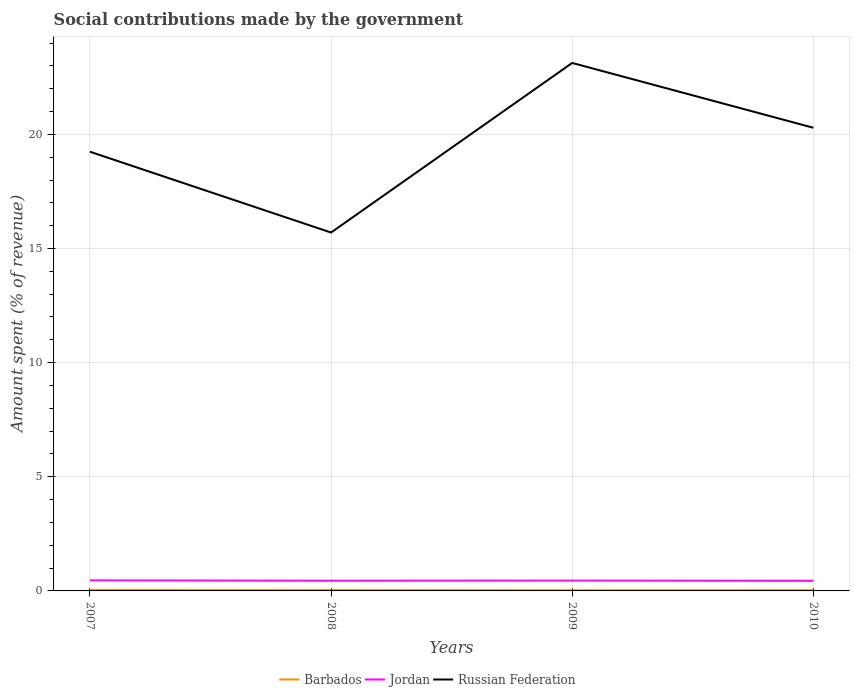Does the line corresponding to Russian Federation intersect with the line corresponding to Jordan?
Give a very brief answer. No. Is the number of lines equal to the number of legend labels?
Your answer should be compact. Yes. Across all years, what is the maximum amount spent (in %) on social contributions in Barbados?
Your response must be concise. 0.03. What is the total amount spent (in %) on social contributions in Jordan in the graph?
Offer a terse response. 0.01. What is the difference between the highest and the second highest amount spent (in %) on social contributions in Jordan?
Your response must be concise. 0.02. Is the amount spent (in %) on social contributions in Barbados strictly greater than the amount spent (in %) on social contributions in Jordan over the years?
Make the answer very short. Yes. How many lines are there?
Provide a succinct answer. 3. What is the difference between two consecutive major ticks on the Y-axis?
Keep it short and to the point. 5. Does the graph contain any zero values?
Your answer should be very brief. No. Where does the legend appear in the graph?
Provide a short and direct response. Bottom center. What is the title of the graph?
Offer a terse response. Social contributions made by the government. What is the label or title of the Y-axis?
Your answer should be compact. Amount spent (% of revenue). What is the Amount spent (% of revenue) in Barbados in 2007?
Offer a very short reply. 0.04. What is the Amount spent (% of revenue) of Jordan in 2007?
Provide a succinct answer. 0.46. What is the Amount spent (% of revenue) in Russian Federation in 2007?
Make the answer very short. 19.24. What is the Amount spent (% of revenue) of Barbados in 2008?
Provide a short and direct response. 0.04. What is the Amount spent (% of revenue) in Jordan in 2008?
Your response must be concise. 0.45. What is the Amount spent (% of revenue) in Russian Federation in 2008?
Make the answer very short. 15.7. What is the Amount spent (% of revenue) of Barbados in 2009?
Your answer should be very brief. 0.03. What is the Amount spent (% of revenue) in Jordan in 2009?
Your answer should be very brief. 0.45. What is the Amount spent (% of revenue) of Russian Federation in 2009?
Keep it short and to the point. 23.13. What is the Amount spent (% of revenue) in Barbados in 2010?
Offer a very short reply. 0.03. What is the Amount spent (% of revenue) in Jordan in 2010?
Keep it short and to the point. 0.44. What is the Amount spent (% of revenue) of Russian Federation in 2010?
Make the answer very short. 20.29. Across all years, what is the maximum Amount spent (% of revenue) of Barbados?
Provide a short and direct response. 0.04. Across all years, what is the maximum Amount spent (% of revenue) of Jordan?
Your response must be concise. 0.46. Across all years, what is the maximum Amount spent (% of revenue) in Russian Federation?
Provide a succinct answer. 23.13. Across all years, what is the minimum Amount spent (% of revenue) in Barbados?
Provide a succinct answer. 0.03. Across all years, what is the minimum Amount spent (% of revenue) in Jordan?
Provide a succinct answer. 0.44. Across all years, what is the minimum Amount spent (% of revenue) in Russian Federation?
Your answer should be compact. 15.7. What is the total Amount spent (% of revenue) in Barbados in the graph?
Your response must be concise. 0.14. What is the total Amount spent (% of revenue) in Jordan in the graph?
Keep it short and to the point. 1.81. What is the total Amount spent (% of revenue) of Russian Federation in the graph?
Ensure brevity in your answer.  78.36. What is the difference between the Amount spent (% of revenue) in Barbados in 2007 and that in 2008?
Offer a terse response. 0. What is the difference between the Amount spent (% of revenue) in Jordan in 2007 and that in 2008?
Provide a short and direct response. 0.01. What is the difference between the Amount spent (% of revenue) in Russian Federation in 2007 and that in 2008?
Keep it short and to the point. 3.54. What is the difference between the Amount spent (% of revenue) of Barbados in 2007 and that in 2009?
Your answer should be compact. 0.01. What is the difference between the Amount spent (% of revenue) of Jordan in 2007 and that in 2009?
Your response must be concise. 0.01. What is the difference between the Amount spent (% of revenue) in Russian Federation in 2007 and that in 2009?
Your answer should be compact. -3.89. What is the difference between the Amount spent (% of revenue) in Barbados in 2007 and that in 2010?
Provide a short and direct response. 0.01. What is the difference between the Amount spent (% of revenue) of Jordan in 2007 and that in 2010?
Your answer should be very brief. 0.02. What is the difference between the Amount spent (% of revenue) of Russian Federation in 2007 and that in 2010?
Provide a succinct answer. -1.05. What is the difference between the Amount spent (% of revenue) in Barbados in 2008 and that in 2009?
Keep it short and to the point. 0.01. What is the difference between the Amount spent (% of revenue) of Jordan in 2008 and that in 2009?
Your answer should be compact. -0.01. What is the difference between the Amount spent (% of revenue) in Russian Federation in 2008 and that in 2009?
Provide a succinct answer. -7.43. What is the difference between the Amount spent (% of revenue) of Barbados in 2008 and that in 2010?
Provide a succinct answer. 0. What is the difference between the Amount spent (% of revenue) in Jordan in 2008 and that in 2010?
Your answer should be compact. 0. What is the difference between the Amount spent (% of revenue) of Russian Federation in 2008 and that in 2010?
Offer a terse response. -4.59. What is the difference between the Amount spent (% of revenue) in Barbados in 2009 and that in 2010?
Keep it short and to the point. -0. What is the difference between the Amount spent (% of revenue) of Jordan in 2009 and that in 2010?
Ensure brevity in your answer.  0.01. What is the difference between the Amount spent (% of revenue) in Russian Federation in 2009 and that in 2010?
Your answer should be very brief. 2.84. What is the difference between the Amount spent (% of revenue) of Barbados in 2007 and the Amount spent (% of revenue) of Jordan in 2008?
Your answer should be compact. -0.41. What is the difference between the Amount spent (% of revenue) of Barbados in 2007 and the Amount spent (% of revenue) of Russian Federation in 2008?
Ensure brevity in your answer.  -15.66. What is the difference between the Amount spent (% of revenue) in Jordan in 2007 and the Amount spent (% of revenue) in Russian Federation in 2008?
Your response must be concise. -15.24. What is the difference between the Amount spent (% of revenue) of Barbados in 2007 and the Amount spent (% of revenue) of Jordan in 2009?
Keep it short and to the point. -0.41. What is the difference between the Amount spent (% of revenue) in Barbados in 2007 and the Amount spent (% of revenue) in Russian Federation in 2009?
Your answer should be compact. -23.09. What is the difference between the Amount spent (% of revenue) in Jordan in 2007 and the Amount spent (% of revenue) in Russian Federation in 2009?
Your response must be concise. -22.67. What is the difference between the Amount spent (% of revenue) of Barbados in 2007 and the Amount spent (% of revenue) of Jordan in 2010?
Your answer should be compact. -0.4. What is the difference between the Amount spent (% of revenue) in Barbados in 2007 and the Amount spent (% of revenue) in Russian Federation in 2010?
Your answer should be very brief. -20.25. What is the difference between the Amount spent (% of revenue) of Jordan in 2007 and the Amount spent (% of revenue) of Russian Federation in 2010?
Your answer should be compact. -19.83. What is the difference between the Amount spent (% of revenue) of Barbados in 2008 and the Amount spent (% of revenue) of Jordan in 2009?
Provide a succinct answer. -0.42. What is the difference between the Amount spent (% of revenue) in Barbados in 2008 and the Amount spent (% of revenue) in Russian Federation in 2009?
Provide a succinct answer. -23.09. What is the difference between the Amount spent (% of revenue) in Jordan in 2008 and the Amount spent (% of revenue) in Russian Federation in 2009?
Provide a short and direct response. -22.68. What is the difference between the Amount spent (% of revenue) in Barbados in 2008 and the Amount spent (% of revenue) in Jordan in 2010?
Provide a short and direct response. -0.41. What is the difference between the Amount spent (% of revenue) of Barbados in 2008 and the Amount spent (% of revenue) of Russian Federation in 2010?
Give a very brief answer. -20.25. What is the difference between the Amount spent (% of revenue) of Jordan in 2008 and the Amount spent (% of revenue) of Russian Federation in 2010?
Your response must be concise. -19.84. What is the difference between the Amount spent (% of revenue) of Barbados in 2009 and the Amount spent (% of revenue) of Jordan in 2010?
Your answer should be compact. -0.41. What is the difference between the Amount spent (% of revenue) in Barbados in 2009 and the Amount spent (% of revenue) in Russian Federation in 2010?
Provide a succinct answer. -20.26. What is the difference between the Amount spent (% of revenue) of Jordan in 2009 and the Amount spent (% of revenue) of Russian Federation in 2010?
Give a very brief answer. -19.84. What is the average Amount spent (% of revenue) in Barbados per year?
Ensure brevity in your answer.  0.03. What is the average Amount spent (% of revenue) of Jordan per year?
Provide a short and direct response. 0.45. What is the average Amount spent (% of revenue) of Russian Federation per year?
Your answer should be very brief. 19.59. In the year 2007, what is the difference between the Amount spent (% of revenue) in Barbados and Amount spent (% of revenue) in Jordan?
Offer a very short reply. -0.42. In the year 2007, what is the difference between the Amount spent (% of revenue) of Barbados and Amount spent (% of revenue) of Russian Federation?
Offer a very short reply. -19.2. In the year 2007, what is the difference between the Amount spent (% of revenue) of Jordan and Amount spent (% of revenue) of Russian Federation?
Provide a short and direct response. -18.78. In the year 2008, what is the difference between the Amount spent (% of revenue) of Barbados and Amount spent (% of revenue) of Jordan?
Your answer should be compact. -0.41. In the year 2008, what is the difference between the Amount spent (% of revenue) of Barbados and Amount spent (% of revenue) of Russian Federation?
Ensure brevity in your answer.  -15.66. In the year 2008, what is the difference between the Amount spent (% of revenue) in Jordan and Amount spent (% of revenue) in Russian Federation?
Provide a short and direct response. -15.25. In the year 2009, what is the difference between the Amount spent (% of revenue) of Barbados and Amount spent (% of revenue) of Jordan?
Your answer should be very brief. -0.42. In the year 2009, what is the difference between the Amount spent (% of revenue) in Barbados and Amount spent (% of revenue) in Russian Federation?
Ensure brevity in your answer.  -23.1. In the year 2009, what is the difference between the Amount spent (% of revenue) of Jordan and Amount spent (% of revenue) of Russian Federation?
Keep it short and to the point. -22.67. In the year 2010, what is the difference between the Amount spent (% of revenue) of Barbados and Amount spent (% of revenue) of Jordan?
Give a very brief answer. -0.41. In the year 2010, what is the difference between the Amount spent (% of revenue) of Barbados and Amount spent (% of revenue) of Russian Federation?
Your answer should be compact. -20.26. In the year 2010, what is the difference between the Amount spent (% of revenue) of Jordan and Amount spent (% of revenue) of Russian Federation?
Make the answer very short. -19.85. What is the ratio of the Amount spent (% of revenue) of Barbados in 2007 to that in 2008?
Offer a terse response. 1.12. What is the ratio of the Amount spent (% of revenue) of Jordan in 2007 to that in 2008?
Ensure brevity in your answer.  1.03. What is the ratio of the Amount spent (% of revenue) in Russian Federation in 2007 to that in 2008?
Your answer should be very brief. 1.23. What is the ratio of the Amount spent (% of revenue) of Barbados in 2007 to that in 2009?
Provide a succinct answer. 1.35. What is the ratio of the Amount spent (% of revenue) of Jordan in 2007 to that in 2009?
Your answer should be compact. 1.02. What is the ratio of the Amount spent (% of revenue) of Russian Federation in 2007 to that in 2009?
Offer a terse response. 0.83. What is the ratio of the Amount spent (% of revenue) in Barbados in 2007 to that in 2010?
Your answer should be compact. 1.25. What is the ratio of the Amount spent (% of revenue) of Jordan in 2007 to that in 2010?
Your answer should be very brief. 1.04. What is the ratio of the Amount spent (% of revenue) of Russian Federation in 2007 to that in 2010?
Keep it short and to the point. 0.95. What is the ratio of the Amount spent (% of revenue) of Barbados in 2008 to that in 2009?
Provide a short and direct response. 1.21. What is the ratio of the Amount spent (% of revenue) in Jordan in 2008 to that in 2009?
Offer a very short reply. 0.99. What is the ratio of the Amount spent (% of revenue) in Russian Federation in 2008 to that in 2009?
Ensure brevity in your answer.  0.68. What is the ratio of the Amount spent (% of revenue) in Barbados in 2008 to that in 2010?
Your answer should be very brief. 1.12. What is the ratio of the Amount spent (% of revenue) of Jordan in 2008 to that in 2010?
Your answer should be very brief. 1.01. What is the ratio of the Amount spent (% of revenue) of Russian Federation in 2008 to that in 2010?
Make the answer very short. 0.77. What is the ratio of the Amount spent (% of revenue) of Barbados in 2009 to that in 2010?
Ensure brevity in your answer.  0.92. What is the ratio of the Amount spent (% of revenue) of Jordan in 2009 to that in 2010?
Provide a short and direct response. 1.02. What is the ratio of the Amount spent (% of revenue) of Russian Federation in 2009 to that in 2010?
Make the answer very short. 1.14. What is the difference between the highest and the second highest Amount spent (% of revenue) of Barbados?
Keep it short and to the point. 0. What is the difference between the highest and the second highest Amount spent (% of revenue) of Jordan?
Provide a short and direct response. 0.01. What is the difference between the highest and the second highest Amount spent (% of revenue) in Russian Federation?
Your answer should be very brief. 2.84. What is the difference between the highest and the lowest Amount spent (% of revenue) of Barbados?
Offer a terse response. 0.01. What is the difference between the highest and the lowest Amount spent (% of revenue) of Jordan?
Keep it short and to the point. 0.02. What is the difference between the highest and the lowest Amount spent (% of revenue) of Russian Federation?
Keep it short and to the point. 7.43. 